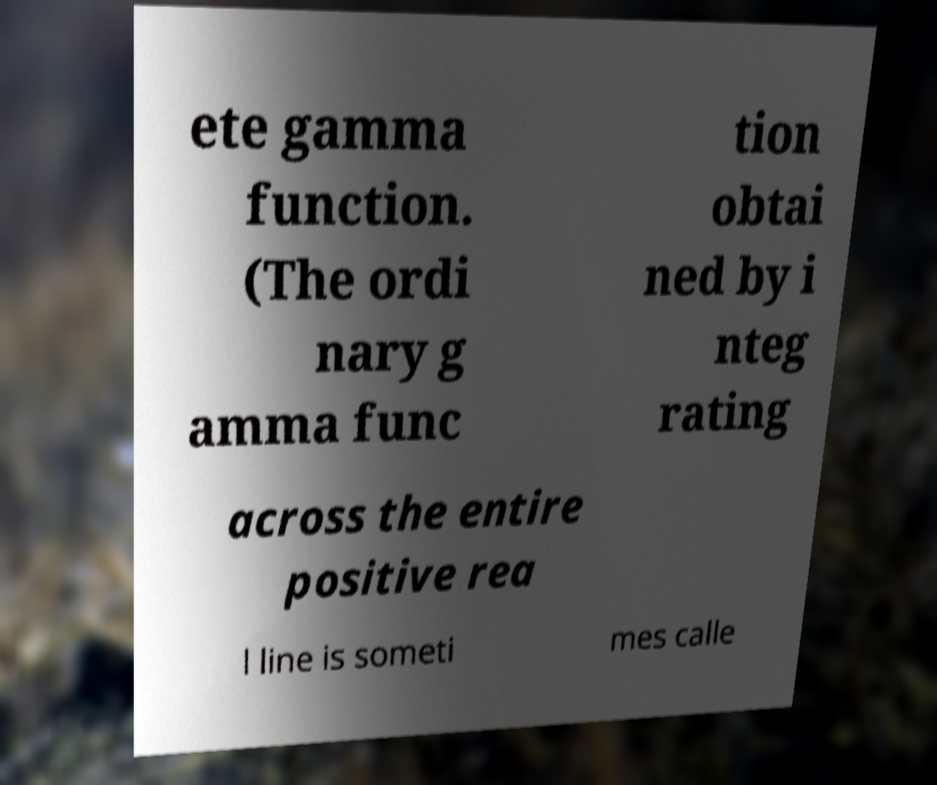Can you read and provide the text displayed in the image?This photo seems to have some interesting text. Can you extract and type it out for me? ete gamma function. (The ordi nary g amma func tion obtai ned by i nteg rating across the entire positive rea l line is someti mes calle 